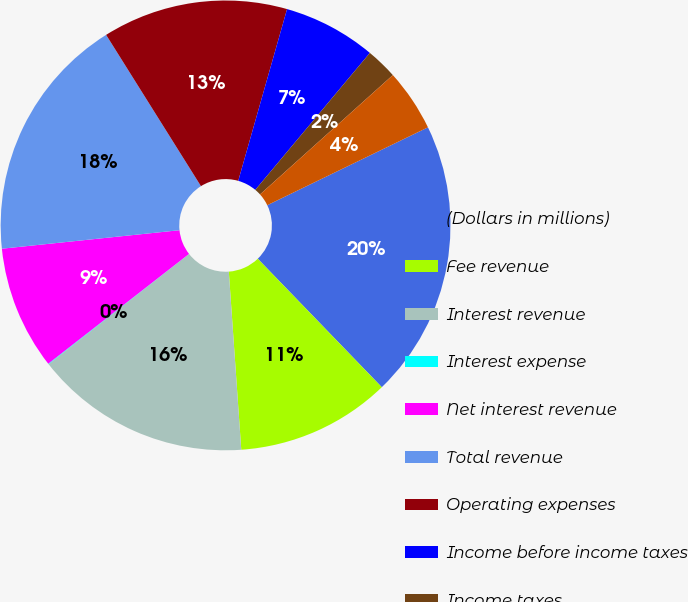<chart> <loc_0><loc_0><loc_500><loc_500><pie_chart><fcel>(Dollars in millions)<fcel>Fee revenue<fcel>Interest revenue<fcel>Interest expense<fcel>Net interest revenue<fcel>Total revenue<fcel>Operating expenses<fcel>Income before income taxes<fcel>Income taxes<fcel>Net Income<nl><fcel>19.96%<fcel>11.11%<fcel>15.53%<fcel>0.04%<fcel>8.89%<fcel>17.74%<fcel>13.32%<fcel>6.68%<fcel>2.26%<fcel>4.47%<nl></chart> 